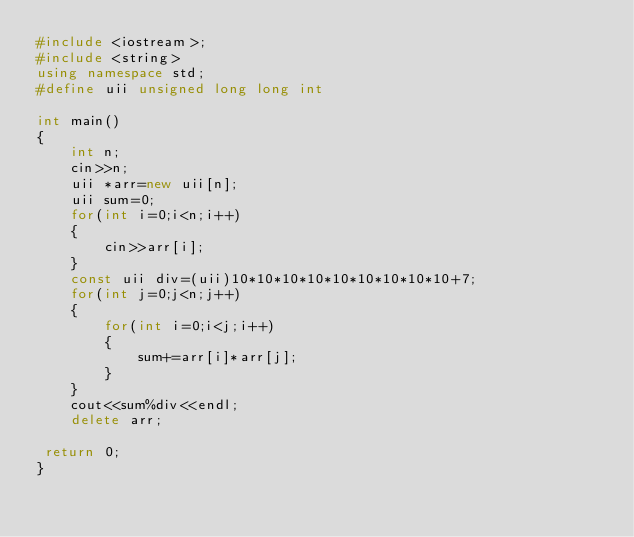Convert code to text. <code><loc_0><loc_0><loc_500><loc_500><_C++_>#include <iostream>;
#include <string>
using namespace std;
#define uii unsigned long long int

int main()
{
    int n;
    cin>>n;
    uii *arr=new uii[n];
    uii sum=0;
    for(int i=0;i<n;i++)
    {
        cin>>arr[i];
    }
    const uii div=(uii)10*10*10*10*10*10*10*10*10+7;
    for(int j=0;j<n;j++)
    {
        for(int i=0;i<j;i++)
        {
            sum+=arr[i]*arr[j];
        }
    }
    cout<<sum%div<<endl;
    delete arr;

 return 0;
}
</code> 